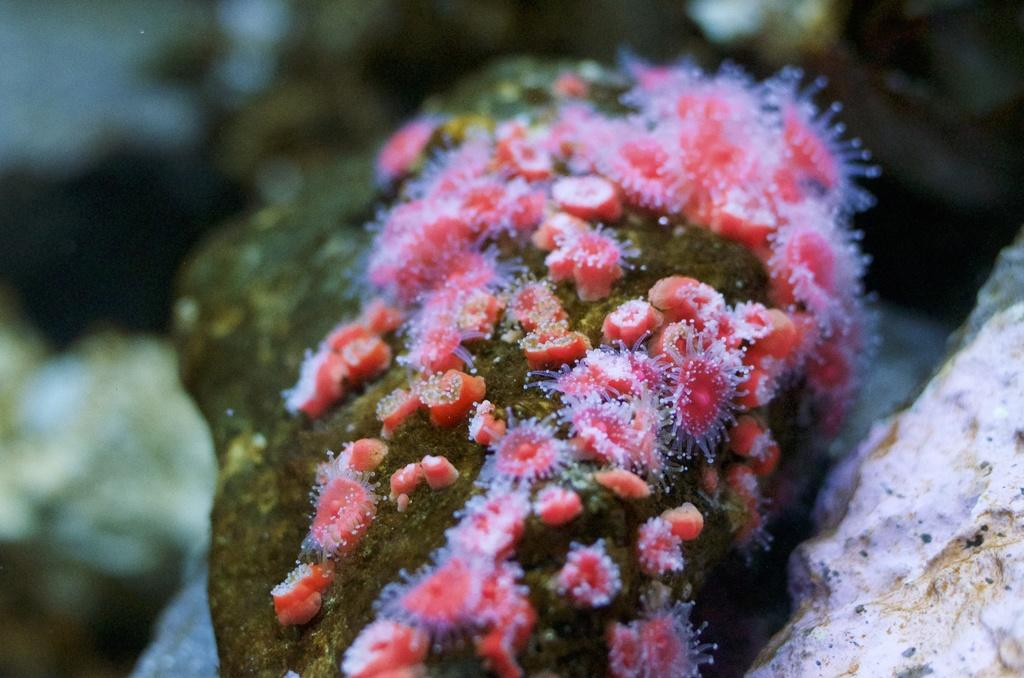What is the main subject of the image? The main subject of the image is a rock. Are there any other elements present on the rock? Yes, there is bacteria on the rock. What color is the bacteria? The bacteria is in red color. What advice does the rock give to the bacteria in the image? There is no interaction or communication between the rock and the bacteria in the image, so it is not possible to determine any advice given. 